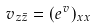Convert formula to latex. <formula><loc_0><loc_0><loc_500><loc_500>v _ { z \bar { z } } = ( e ^ { v } ) _ { x x }</formula> 